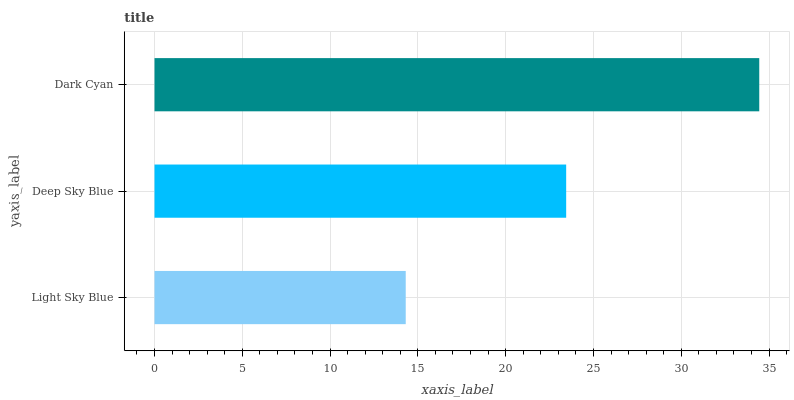Is Light Sky Blue the minimum?
Answer yes or no. Yes. Is Dark Cyan the maximum?
Answer yes or no. Yes. Is Deep Sky Blue the minimum?
Answer yes or no. No. Is Deep Sky Blue the maximum?
Answer yes or no. No. Is Deep Sky Blue greater than Light Sky Blue?
Answer yes or no. Yes. Is Light Sky Blue less than Deep Sky Blue?
Answer yes or no. Yes. Is Light Sky Blue greater than Deep Sky Blue?
Answer yes or no. No. Is Deep Sky Blue less than Light Sky Blue?
Answer yes or no. No. Is Deep Sky Blue the high median?
Answer yes or no. Yes. Is Deep Sky Blue the low median?
Answer yes or no. Yes. Is Light Sky Blue the high median?
Answer yes or no. No. Is Dark Cyan the low median?
Answer yes or no. No. 